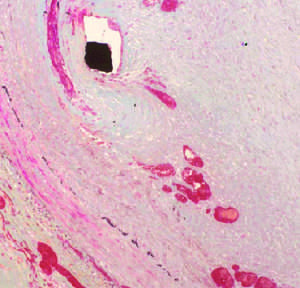what does the histologic view show overlying the stent wires (black diamond indicated by the arrow), which encroaches on the lumen (asterisk)?
Answer the question using a single word or phrase. A thickened neointima 